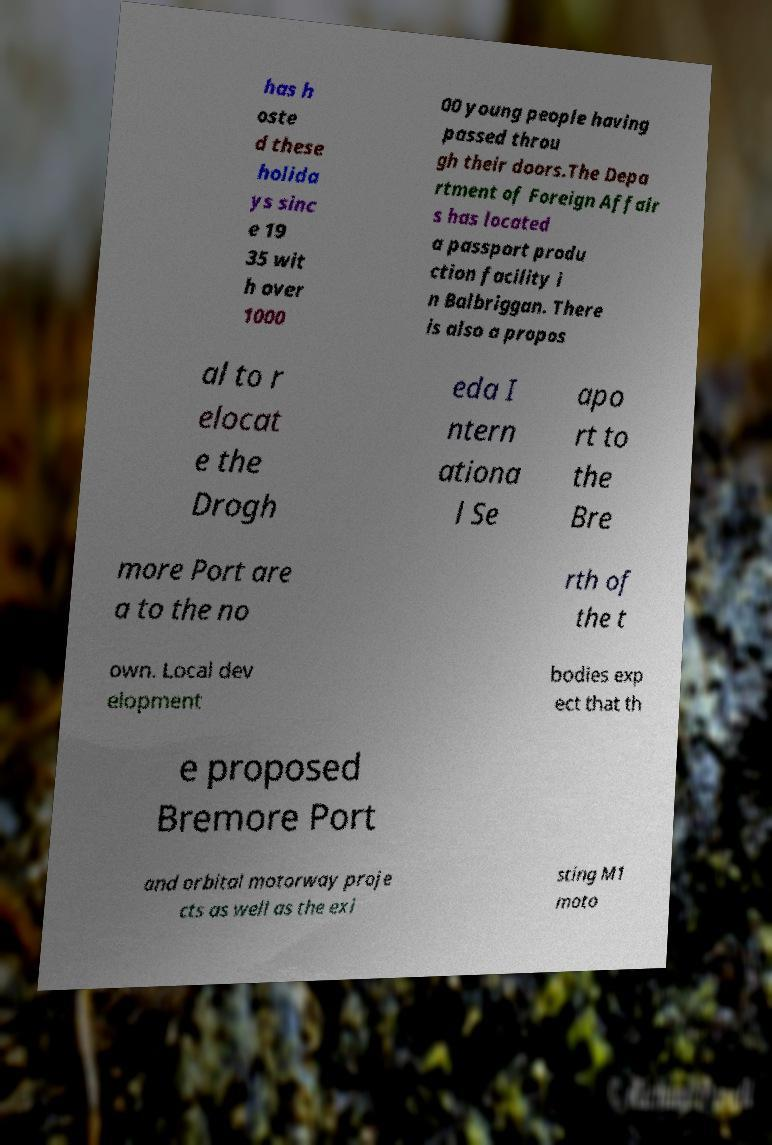There's text embedded in this image that I need extracted. Can you transcribe it verbatim? has h oste d these holida ys sinc e 19 35 wit h over 1000 00 young people having passed throu gh their doors.The Depa rtment of Foreign Affair s has located a passport produ ction facility i n Balbriggan. There is also a propos al to r elocat e the Drogh eda I ntern ationa l Se apo rt to the Bre more Port are a to the no rth of the t own. Local dev elopment bodies exp ect that th e proposed Bremore Port and orbital motorway proje cts as well as the exi sting M1 moto 